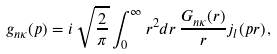Convert formula to latex. <formula><loc_0><loc_0><loc_500><loc_500>g _ { n \kappa } ( p ) = i \, \sqrt { \frac { 2 } { \pi } } \int _ { 0 } ^ { \infty } r ^ { 2 } d r \, \frac { G _ { n \kappa } ( r ) } { r } j _ { l } ( p r ) \, ,</formula> 